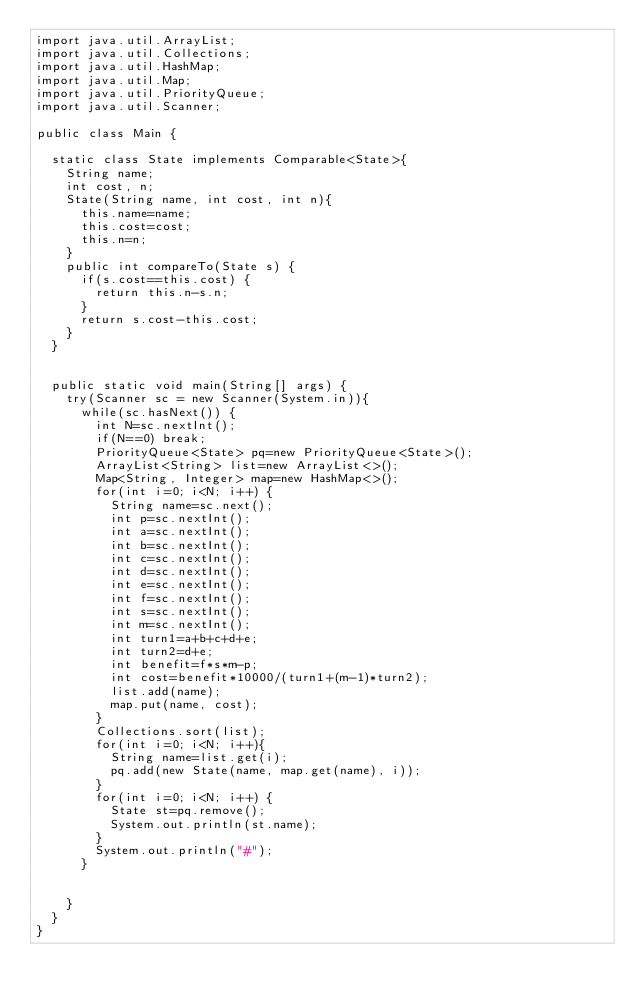Convert code to text. <code><loc_0><loc_0><loc_500><loc_500><_Java_>import java.util.ArrayList;
import java.util.Collections;
import java.util.HashMap;
import java.util.Map;
import java.util.PriorityQueue;
import java.util.Scanner;

public class Main {
	
	static class State implements Comparable<State>{
		String name;
		int cost, n;
		State(String name, int cost, int n){
			this.name=name;
			this.cost=cost;
			this.n=n;
		}
		public int compareTo(State s) {
			if(s.cost==this.cost) {
				return this.n-s.n;
			}
			return s.cost-this.cost;
		}
	}
	
	
	public static void main(String[] args) {
		try(Scanner sc = new Scanner(System.in)){
			while(sc.hasNext()) {
				int N=sc.nextInt();
				if(N==0) break;
				PriorityQueue<State> pq=new PriorityQueue<State>();
				ArrayList<String> list=new ArrayList<>();
				Map<String, Integer> map=new HashMap<>();
				for(int i=0; i<N; i++) {
					String name=sc.next();
					int p=sc.nextInt();
					int a=sc.nextInt();
					int b=sc.nextInt();
					int c=sc.nextInt();
					int d=sc.nextInt();
					int e=sc.nextInt();
					int f=sc.nextInt();
					int s=sc.nextInt();
					int m=sc.nextInt();
					int turn1=a+b+c+d+e;
					int turn2=d+e;
					int benefit=f*s*m-p;
					int cost=benefit*10000/(turn1+(m-1)*turn2);
					list.add(name);
					map.put(name, cost);
				}
				Collections.sort(list);
				for(int i=0; i<N; i++){
					String name=list.get(i);
					pq.add(new State(name, map.get(name), i));
				}
				for(int i=0; i<N; i++) {
					State st=pq.remove();
					System.out.println(st.name);
				}
				System.out.println("#");
			}


		}
	}
}
</code> 